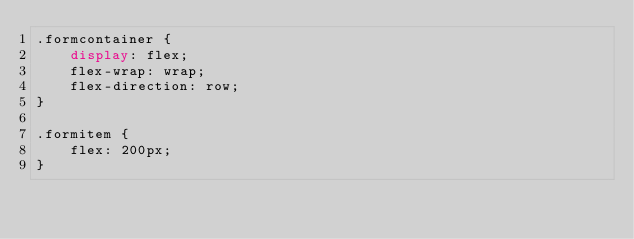<code> <loc_0><loc_0><loc_500><loc_500><_CSS_>.formcontainer {
    display: flex;
    flex-wrap: wrap;
    flex-direction: row;
}

.formitem {
    flex: 200px;
}</code> 